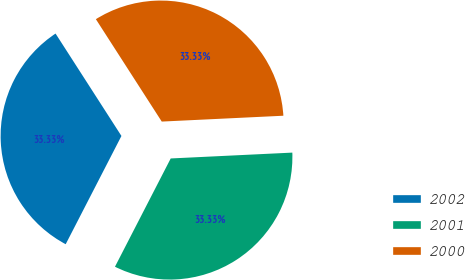Convert chart to OTSL. <chart><loc_0><loc_0><loc_500><loc_500><pie_chart><fcel>2002<fcel>2001<fcel>2000<nl><fcel>33.33%<fcel>33.33%<fcel>33.33%<nl></chart> 